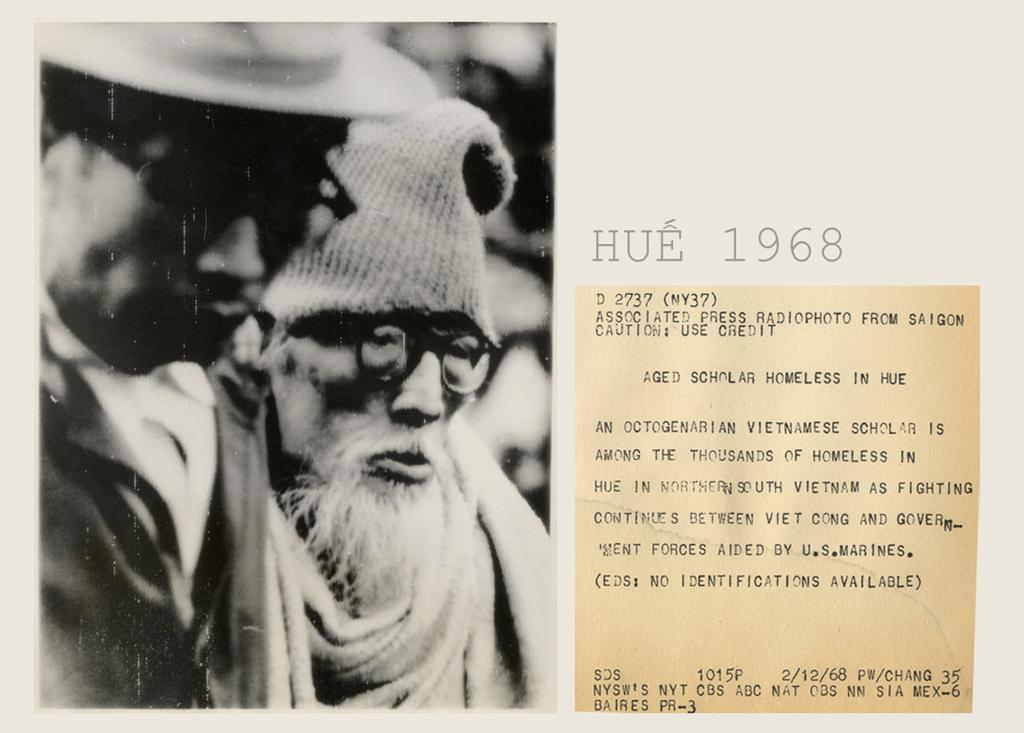What is the main subject of the image? The main subject of the image is a picture of two people. Can you describe what is written in the image? There is something written in the right side of the image. What type of corn is being harvested by the mother in the image? There is no corn or mother present in the image; it features a picture of two people and something written on the right side. 